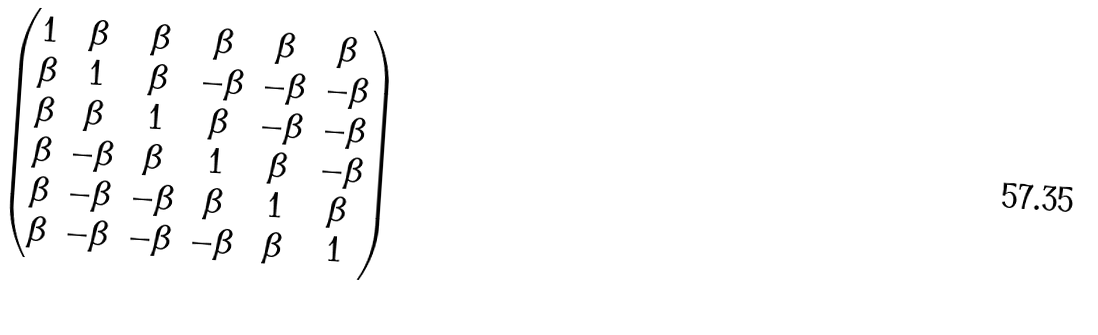Convert formula to latex. <formula><loc_0><loc_0><loc_500><loc_500>\begin{pmatrix} 1 & \beta & \beta & \beta & \beta & \beta \\ \beta & 1 & \beta & - \beta & - \beta & - \beta \\ \beta & \beta & 1 & \beta & - \beta & - \beta \\ \beta & - \beta & \beta & 1 & \beta & - \beta \\ \beta & - \beta & - \beta & \beta & 1 & \beta \\ \beta & - \beta & - \beta & - \beta & \beta & 1 \end{pmatrix}</formula> 